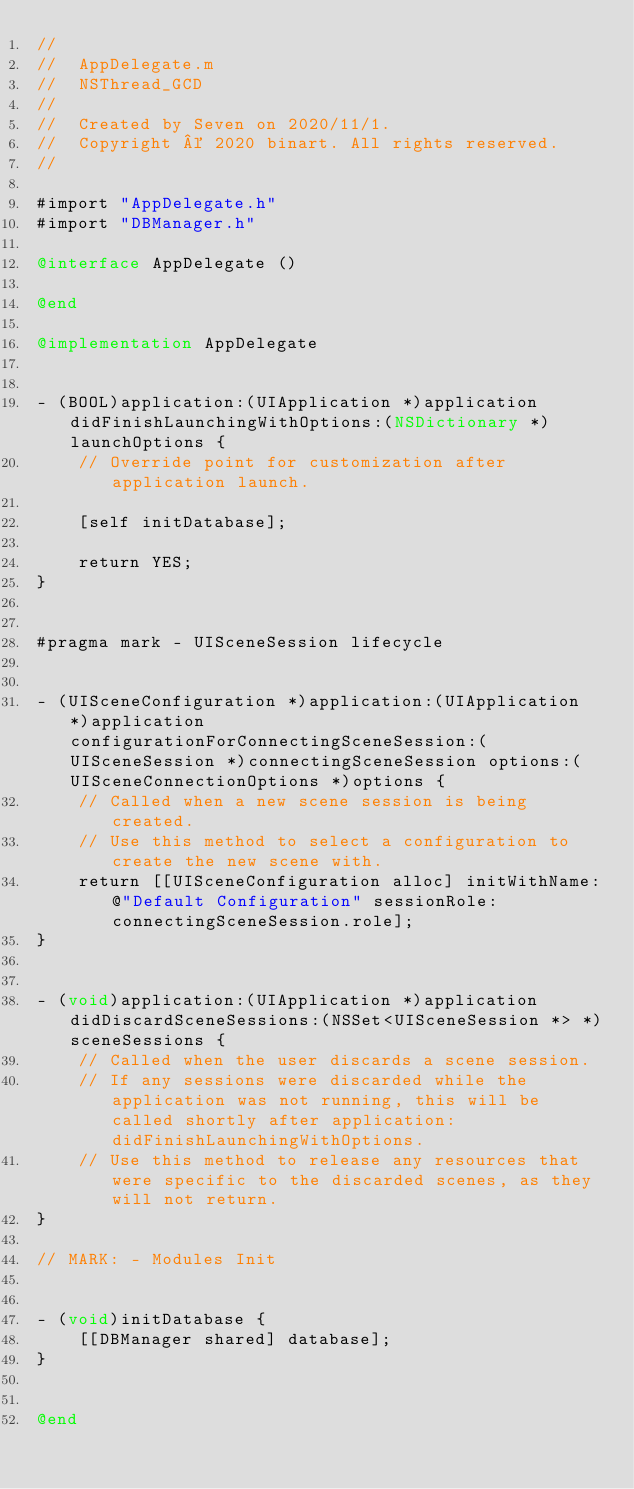Convert code to text. <code><loc_0><loc_0><loc_500><loc_500><_ObjectiveC_>//
//  AppDelegate.m
//  NSThread_GCD
//
//  Created by Seven on 2020/11/1.
//  Copyright © 2020 binart. All rights reserved.
//

#import "AppDelegate.h"
#import "DBManager.h"

@interface AppDelegate ()

@end

@implementation AppDelegate


- (BOOL)application:(UIApplication *)application didFinishLaunchingWithOptions:(NSDictionary *)launchOptions {
    // Override point for customization after application launch.
    
    [self initDatabase];
    
    return YES;
}


#pragma mark - UISceneSession lifecycle


- (UISceneConfiguration *)application:(UIApplication *)application configurationForConnectingSceneSession:(UISceneSession *)connectingSceneSession options:(UISceneConnectionOptions *)options {
    // Called when a new scene session is being created.
    // Use this method to select a configuration to create the new scene with.
    return [[UISceneConfiguration alloc] initWithName:@"Default Configuration" sessionRole:connectingSceneSession.role];
}


- (void)application:(UIApplication *)application didDiscardSceneSessions:(NSSet<UISceneSession *> *)sceneSessions {
    // Called when the user discards a scene session.
    // If any sessions were discarded while the application was not running, this will be called shortly after application:didFinishLaunchingWithOptions.
    // Use this method to release any resources that were specific to the discarded scenes, as they will not return.
}

// MARK: - Modules Init


- (void)initDatabase {
    [[DBManager shared] database];
}


@end
</code> 